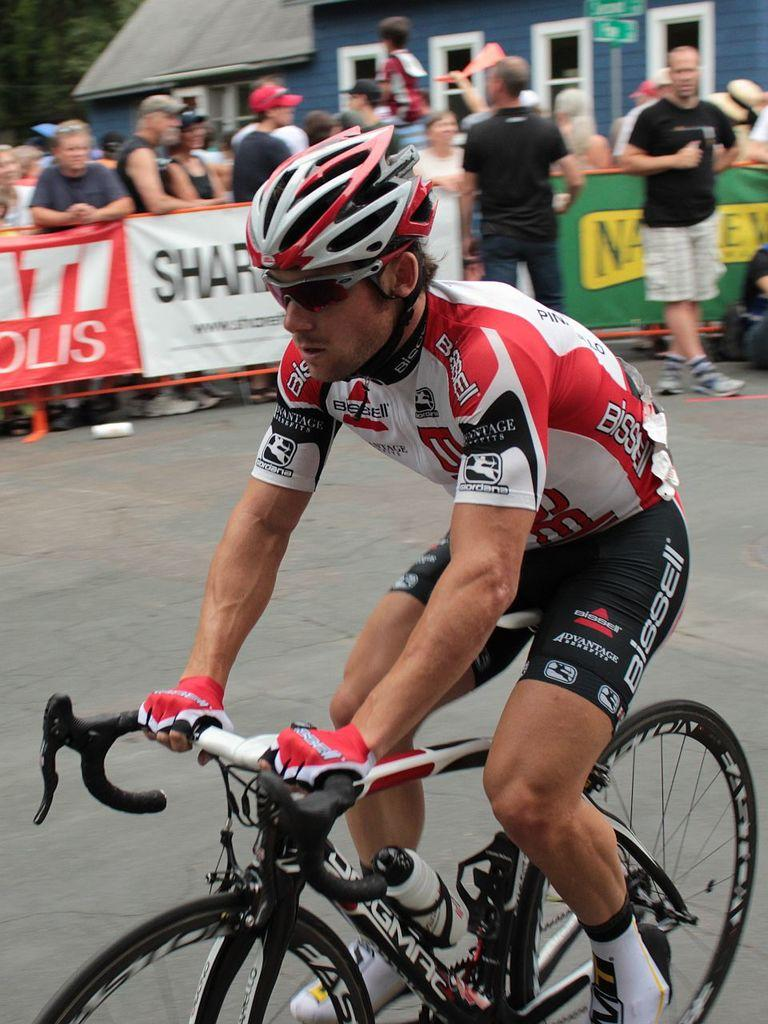What is the main subject of the image? The main subject of the image is a man. What is the man wearing on his face? The man is wearing shades. What is the man wearing on his head? The man is wearing a helmet. What mode of transportation is the man using? The man is on a cycle. What can be seen in the background of the image? There are banners, a lot of people, and a house in the background of the image. What type of knife is the man using to cut the shoes in the image? There is no knife or shoes present in the image; the man is wearing shades, a helmet, and riding a cycle. What color are the shoes the man is rubbing on the ground in the image? There are no shoes or rubbing action present in the image; the man is wearing a helmet and riding a cycle. 